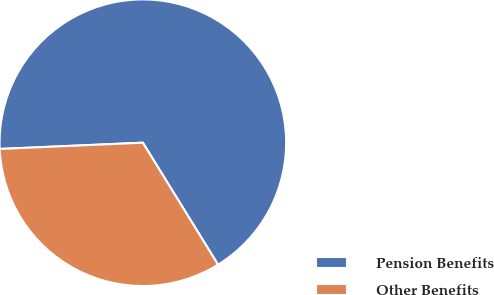<chart> <loc_0><loc_0><loc_500><loc_500><pie_chart><fcel>Pension Benefits<fcel>Other Benefits<nl><fcel>66.9%<fcel>33.1%<nl></chart> 